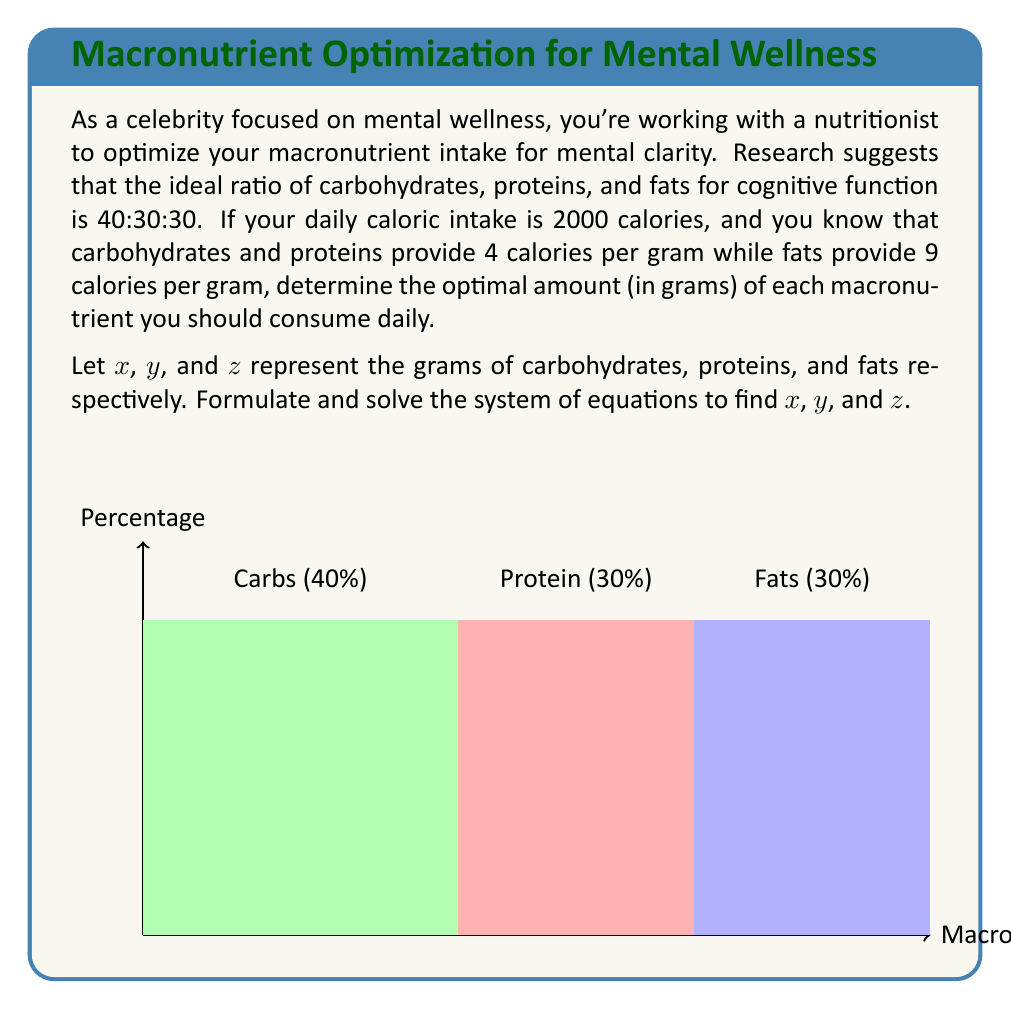Could you help me with this problem? Let's solve this problem step by step:

1) First, we need to set up our equations based on the given information:

   Total calories: $4x + 4y + 9z = 2000$
   Ratio constraint: $x : y : z = 40 : 30 : 30$

2) From the ratio constraint, we can say:
   $y = \frac{3}{4}x$ and $z = \frac{3}{4}x$

3) Substituting these into our calorie equation:

   $4x + 4(\frac{3}{4}x) + 9(\frac{3}{4}x) = 2000$

4) Simplifying:

   $4x + 3x + \frac{27}{4}x = 2000$
   $16x + 12x + 27x = 8000$
   $55x = 8000$

5) Solving for $x$:

   $x = \frac{8000}{55} \approx 145.45$

6) Now we can find $y$ and $z$:

   $y = \frac{3}{4}x = \frac{3}{4} * 145.45 \approx 109.09$
   $z = \frac{3}{4}x = \frac{3}{4} * 145.45 \approx 109.09$

7) Rounding to the nearest gram:

   Carbohydrates ($x$): 145 grams
   Proteins ($y$): 109 grams
   Fats ($z$): 109 grams

8) Verification:
   $(145 * 4) + (109 * 4) + (109 * 9) = 580 + 436 + 981 = 1997$ calories
   (The slight discrepancy is due to rounding)
Answer: Carbohydrates: 145g, Proteins: 109g, Fats: 109g 